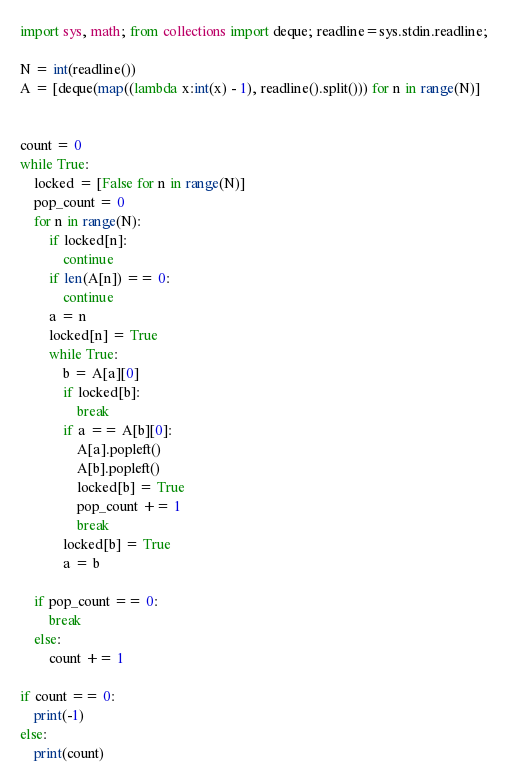<code> <loc_0><loc_0><loc_500><loc_500><_Python_>import sys, math; from collections import deque; readline=sys.stdin.readline;

N = int(readline())
A = [deque(map((lambda x:int(x) - 1), readline().split())) for n in range(N)]


count = 0
while True:
    locked = [False for n in range(N)]
    pop_count = 0
    for n in range(N):
        if locked[n]:
            continue
        if len(A[n]) == 0:
            continue
        a = n
        locked[n] = True
        while True:
            b = A[a][0]
            if locked[b]:
                break
            if a == A[b][0]:
                A[a].popleft()
                A[b].popleft()
                locked[b] = True
                pop_count += 1
                break
            locked[b] = True
            a = b
        
    if pop_count == 0:
        break
    else:
        count += 1

if count == 0:
    print(-1)
else:
    print(count)</code> 